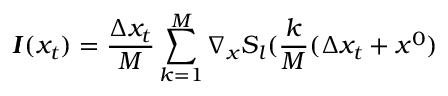Convert formula to latex. <formula><loc_0><loc_0><loc_500><loc_500>\pm b { I } ( x _ { t } ) = \frac { \Delta x _ { t } } { M } \sum _ { k = 1 } ^ { M } \nabla _ { x } S _ { l } ( \frac { k } { M } ( \Delta x _ { t } + x ^ { 0 } )</formula> 